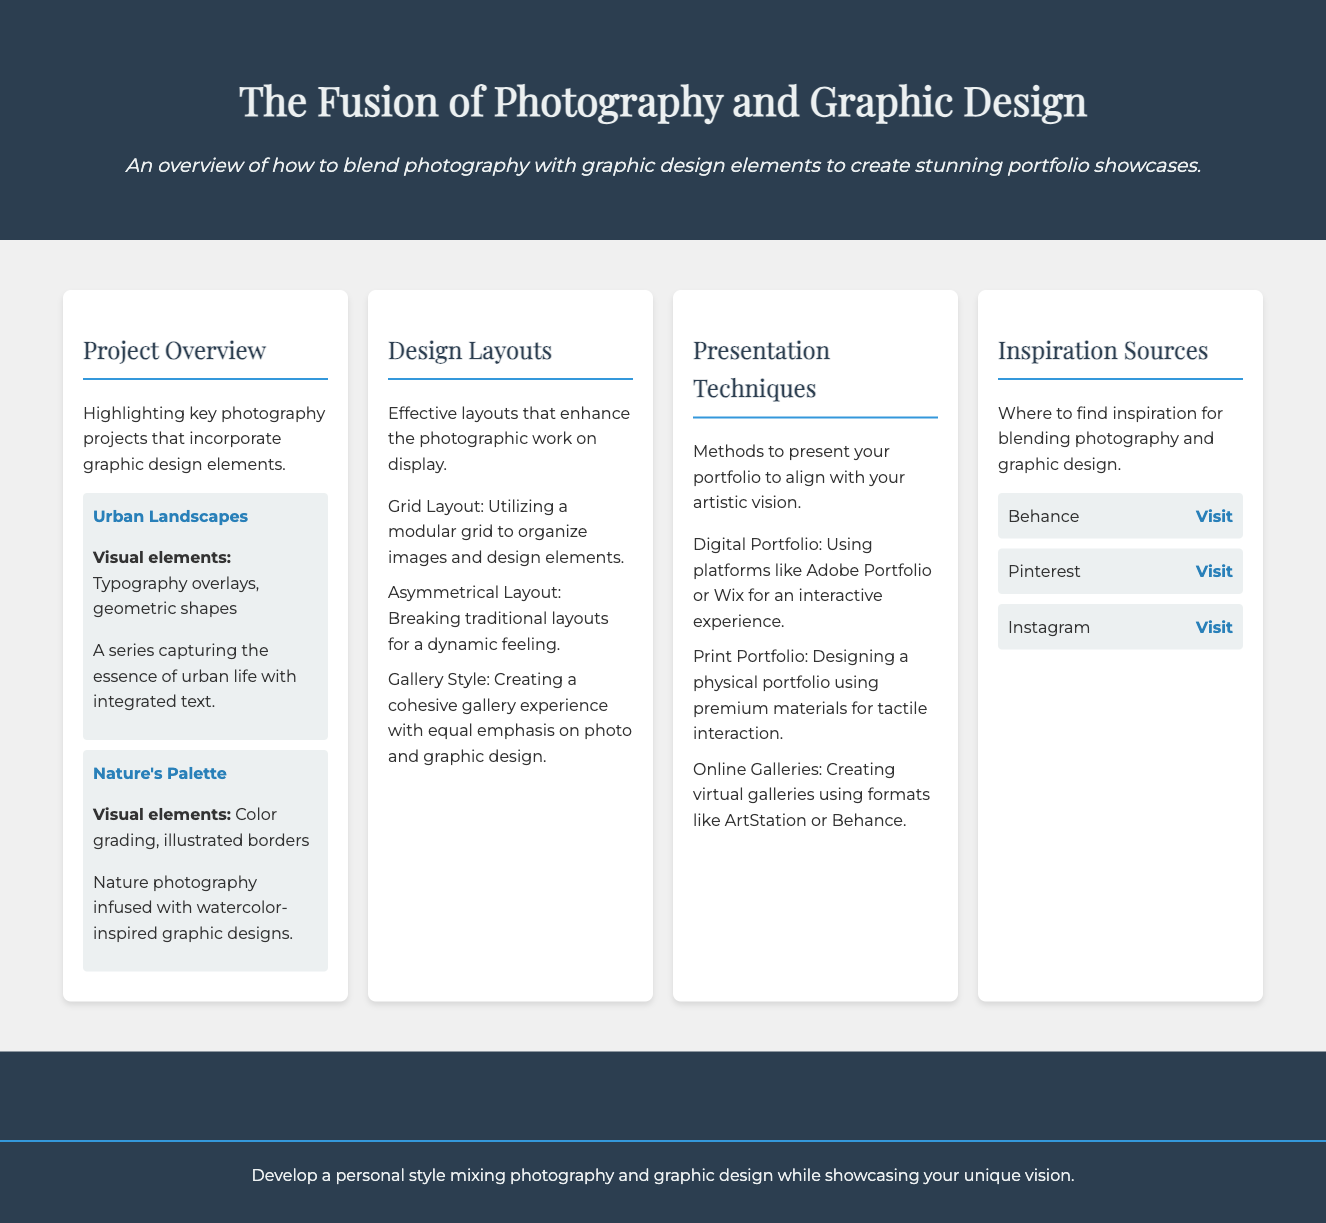what is the title of the document? The title of the document is specified in the <title> tag of the HTML, which describes the focus of the portfolio showcase.
Answer: Photography & Graphic Design Portfolio Showcase how many main menu items are there? The main menu items are listed within the document, counting each section provided in the grid layout.
Answer: 4 name one project from the Project Overview section. The Project Overview section includes a list of photography projects, one of which is specifically mentioned.
Answer: Urban Landscapes what visual elements are used in "Nature's Palette"? The visual elements for "Nature's Palette" are mentioned in a descriptive paragraph within its project information.
Answer: Color grading, illustrated borders what type of portfolio method involves platforms like Adobe Portfolio? The method is described under Presentation Techniques, highlighting options for portfolio presentations.
Answer: Digital Portfolio which layout style creates a cohesive gallery experience? The design layout styles are presented in a concise listing, one of which directly answers the question.
Answer: Gallery Style which source gives access to a collection of creative work for inspiration? The document lists several sources for inspiration, and this is specifically highlighted with a brief description.
Answer: Behance how can one present a physical portfolio? The document specifies presentation methods, including details on creating a tangible portfolio experience.
Answer: Designing a physical portfolio using premium materials 